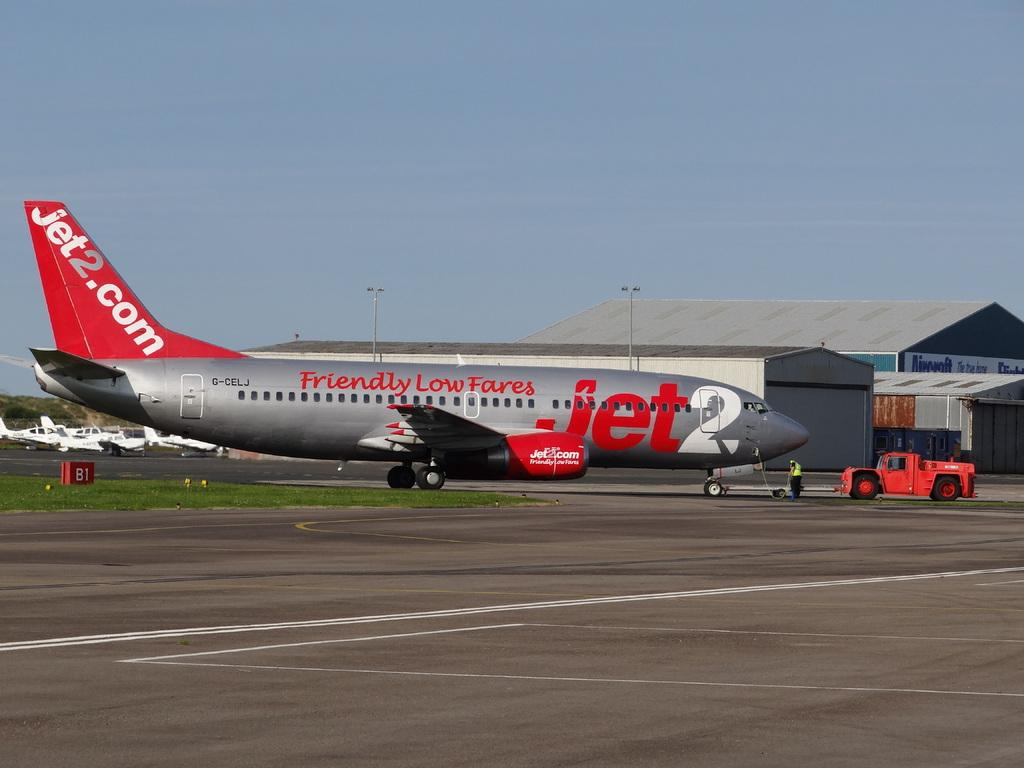<image>
Render a clear and concise summary of the photo. a plane on a runway with Jet2 on the cockpit 